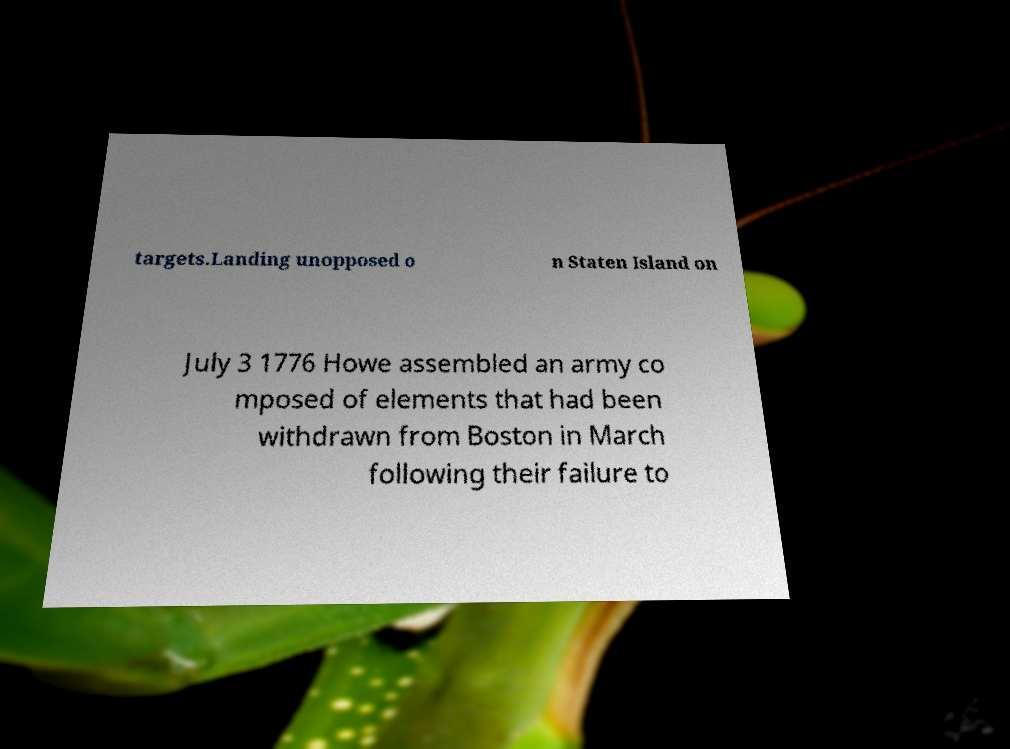Could you assist in decoding the text presented in this image and type it out clearly? targets.Landing unopposed o n Staten Island on July 3 1776 Howe assembled an army co mposed of elements that had been withdrawn from Boston in March following their failure to 